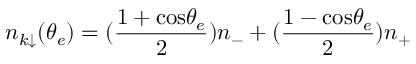<formula> <loc_0><loc_0><loc_500><loc_500>n _ { k \downarrow } ( \theta _ { e } ) = ( { \frac { 1 + \cos \theta _ { e } } { 2 } } ) n _ { - } + ( { \frac { 1 - \cos \theta _ { e } } { 2 } } ) n _ { + }</formula> 